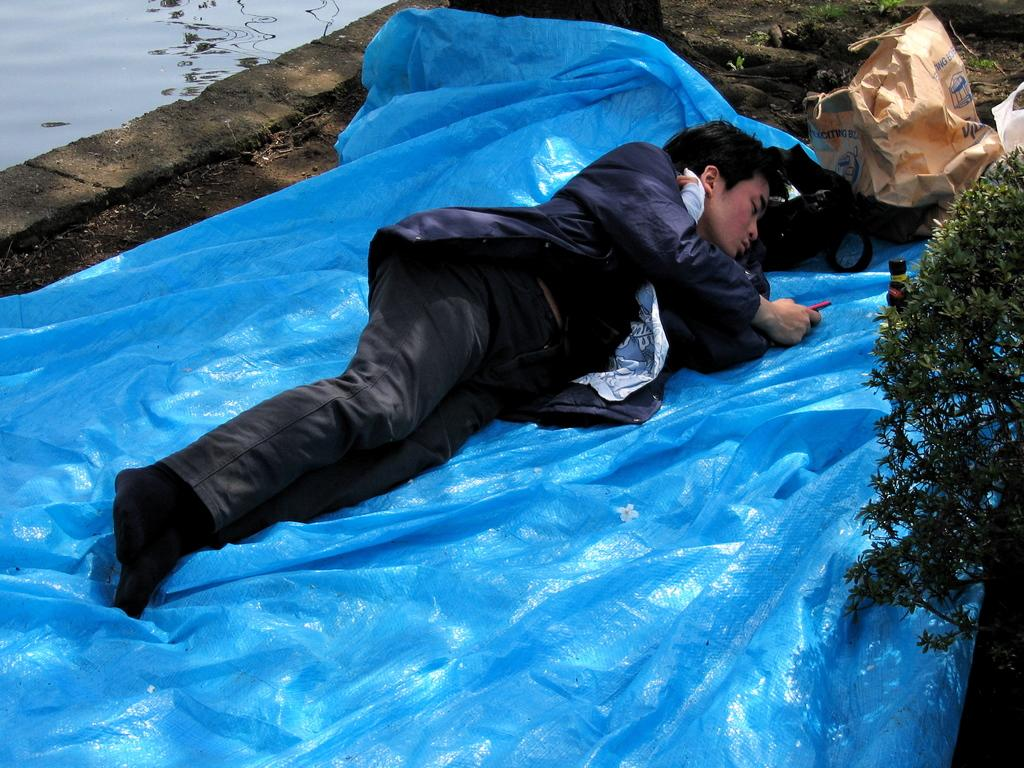What is the main subject in the center of the image? There is a man lying on a sheet in the center of the image. What can be seen on the right side of the image? There is a plant on the right side of the image. What is visible in the background of the image? There are covers visible in the background of the image. What is on the left side of the image? There is water on the left side of the image. What type of skin condition can be seen on the man's face in the image? There is no indication of any skin condition on the man's face in the image. How many goats are present in the image? There are no goats present in the image. 